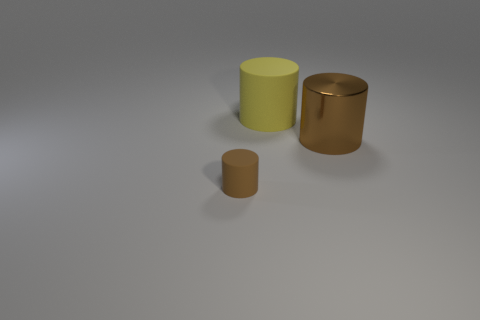Subtract all matte cylinders. How many cylinders are left? 1 Subtract all yellow cylinders. How many cylinders are left? 2 Subtract all red spheres. How many cyan cylinders are left? 0 Subtract all yellow cylinders. Subtract all green spheres. How many cylinders are left? 2 Subtract all matte cylinders. Subtract all big brown metal cylinders. How many objects are left? 0 Add 1 large metallic things. How many large metallic things are left? 2 Add 1 rubber cylinders. How many rubber cylinders exist? 3 Add 2 small brown cylinders. How many objects exist? 5 Subtract 0 red balls. How many objects are left? 3 